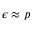<formula> <loc_0><loc_0><loc_500><loc_500>\epsilon \approx p</formula> 